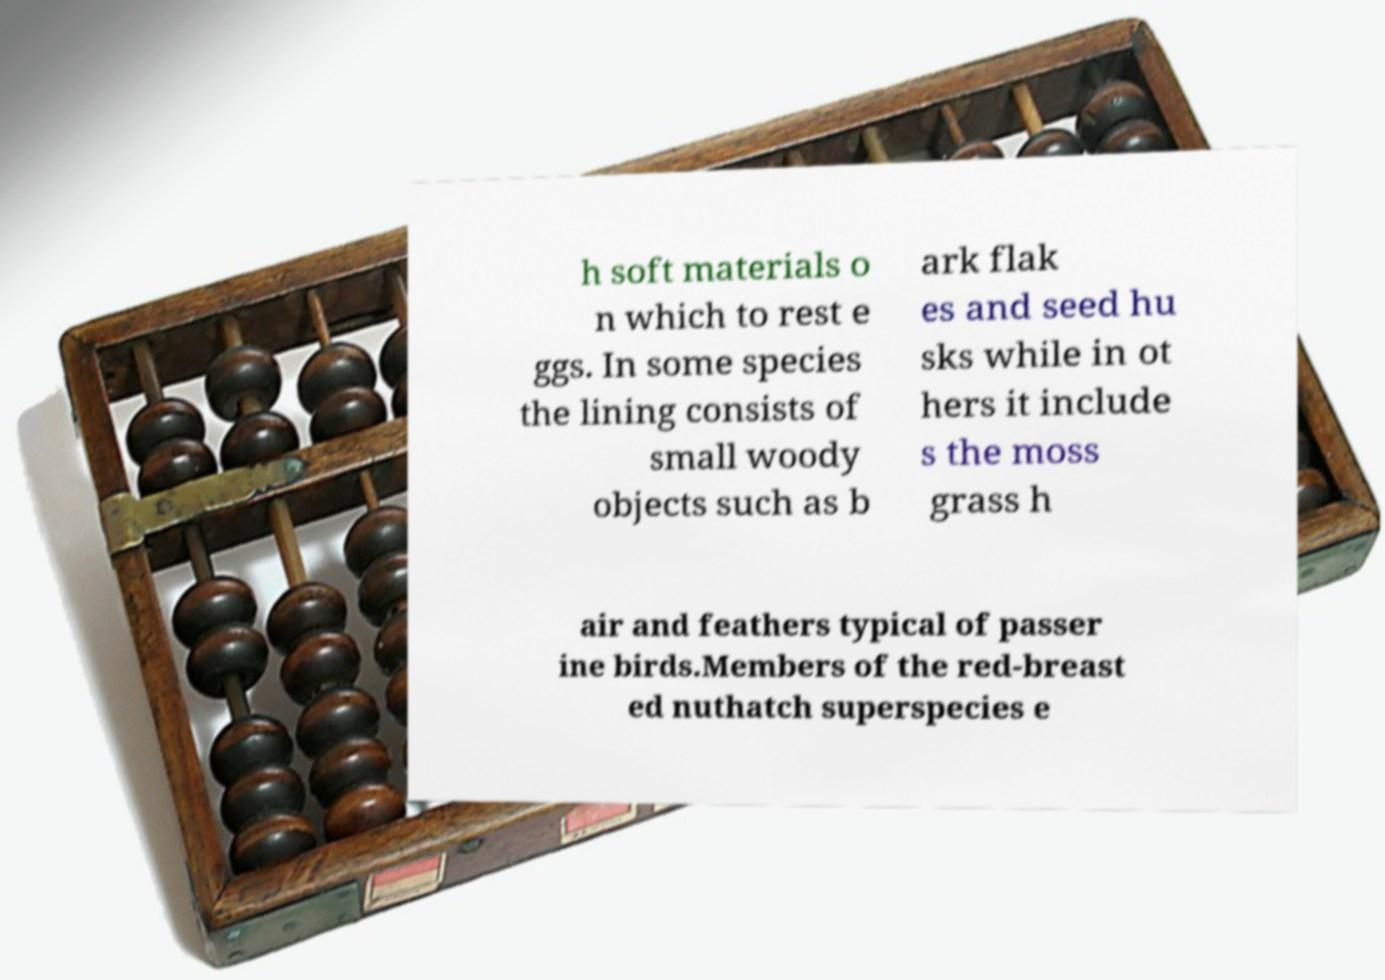There's text embedded in this image that I need extracted. Can you transcribe it verbatim? h soft materials o n which to rest e ggs. In some species the lining consists of small woody objects such as b ark flak es and seed hu sks while in ot hers it include s the moss grass h air and feathers typical of passer ine birds.Members of the red-breast ed nuthatch superspecies e 